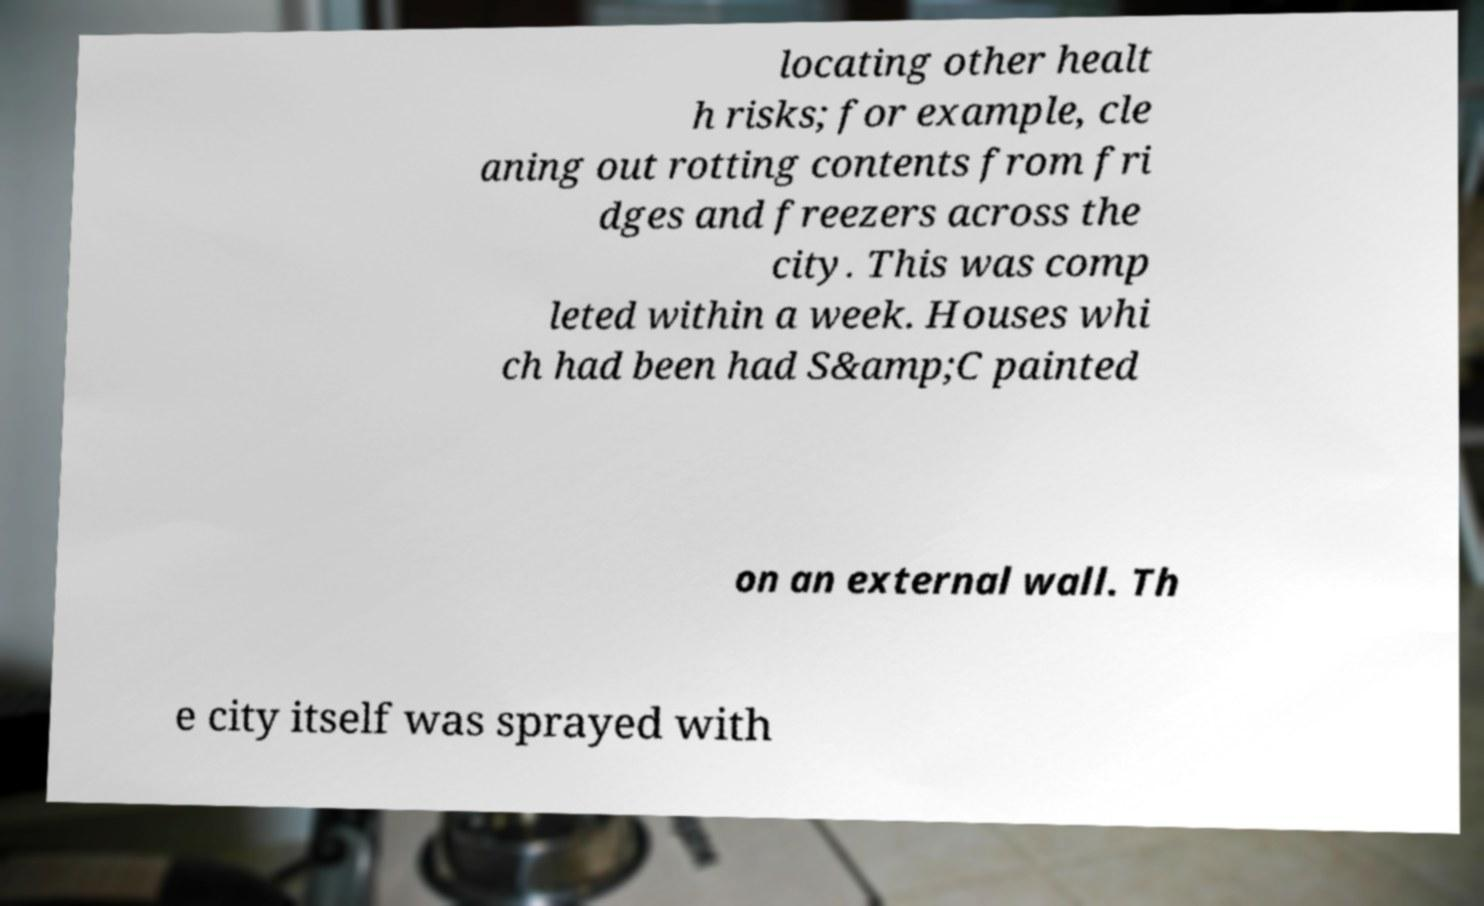Could you assist in decoding the text presented in this image and type it out clearly? locating other healt h risks; for example, cle aning out rotting contents from fri dges and freezers across the city. This was comp leted within a week. Houses whi ch had been had S&amp;C painted on an external wall. Th e city itself was sprayed with 